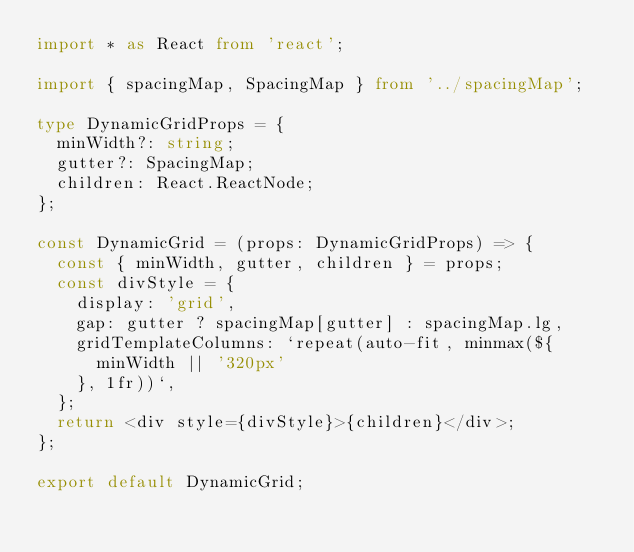Convert code to text. <code><loc_0><loc_0><loc_500><loc_500><_TypeScript_>import * as React from 'react';

import { spacingMap, SpacingMap } from '../spacingMap';

type DynamicGridProps = {
  minWidth?: string;
  gutter?: SpacingMap;
  children: React.ReactNode;
};

const DynamicGrid = (props: DynamicGridProps) => {
  const { minWidth, gutter, children } = props;
  const divStyle = {
    display: 'grid',
    gap: gutter ? spacingMap[gutter] : spacingMap.lg,
    gridTemplateColumns: `repeat(auto-fit, minmax(${
      minWidth || '320px'
    }, 1fr))`,
  };
  return <div style={divStyle}>{children}</div>;
};

export default DynamicGrid;
</code> 